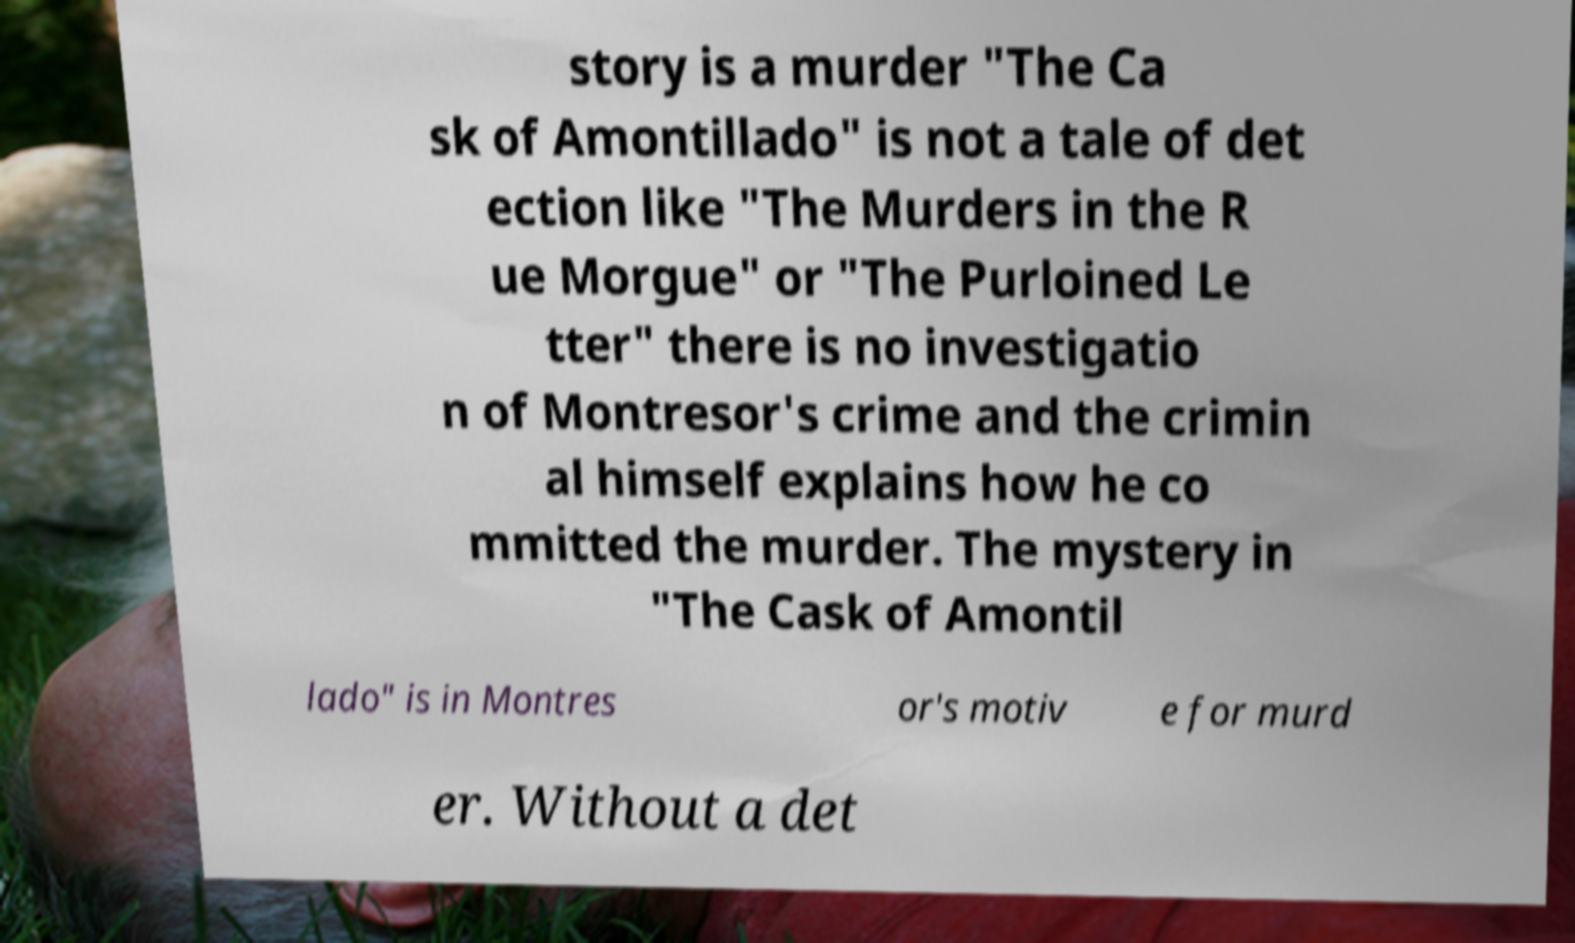Please identify and transcribe the text found in this image. story is a murder "The Ca sk of Amontillado" is not a tale of det ection like "The Murders in the R ue Morgue" or "The Purloined Le tter" there is no investigatio n of Montresor's crime and the crimin al himself explains how he co mmitted the murder. The mystery in "The Cask of Amontil lado" is in Montres or's motiv e for murd er. Without a det 